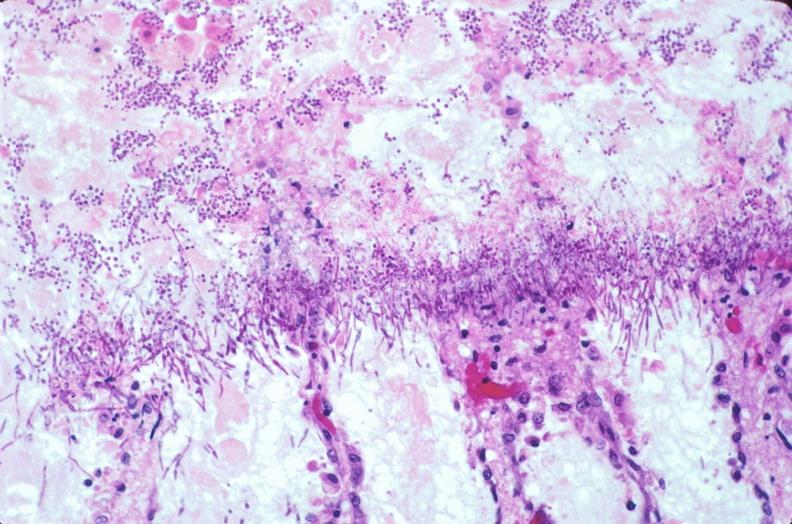where is this from?
Answer the question using a single word or phrase. Gastrointestinal system 